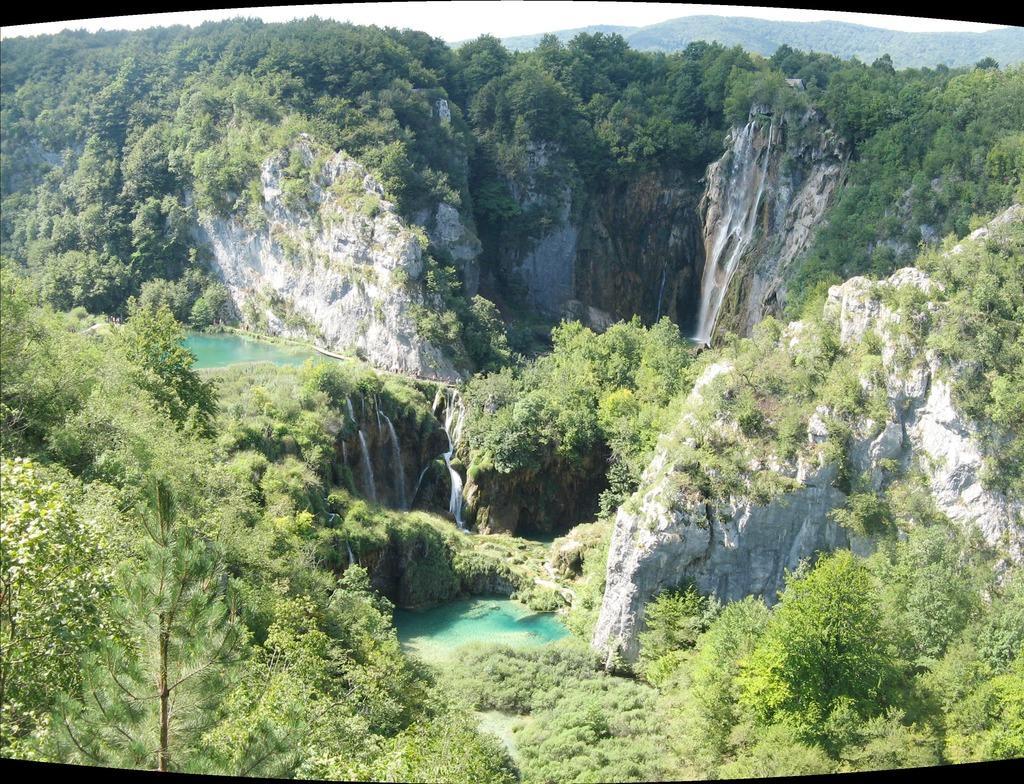How would you summarize this image in a sentence or two? In the center of the image there are mountains. There are trees. There is water. 